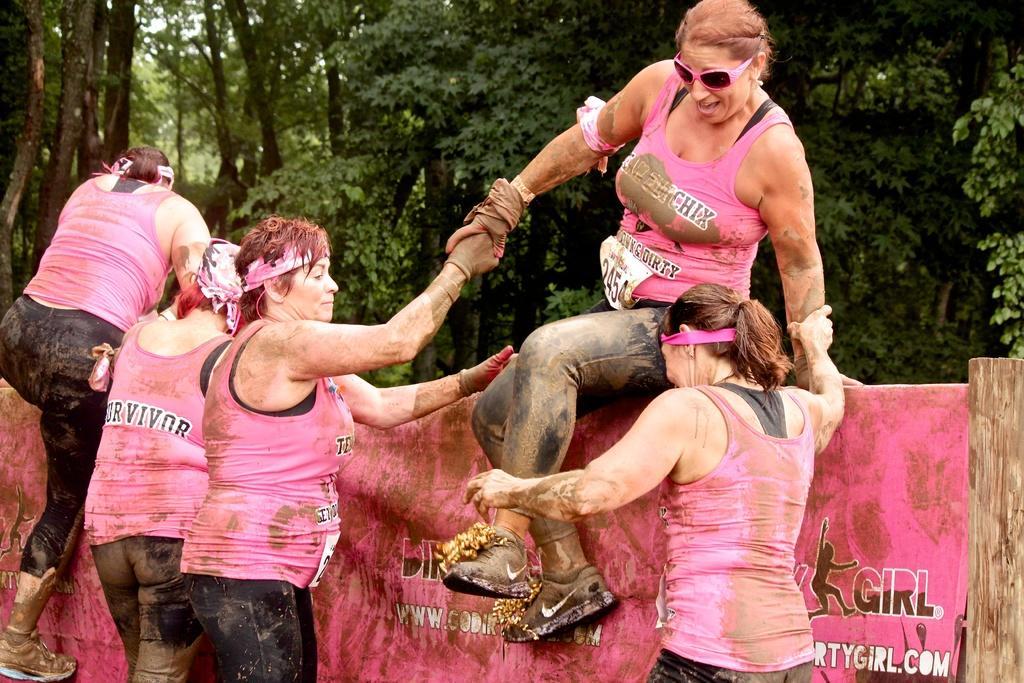In one or two sentences, can you explain what this image depicts? In this picture there is a group of a woman wearing pink color sleeveless top. In the front there is a woman wearing pink top with black and pink sunglasses is climbing a small wall. Behind there are two women who is holding her hand. In the background we can see some huge trees. 